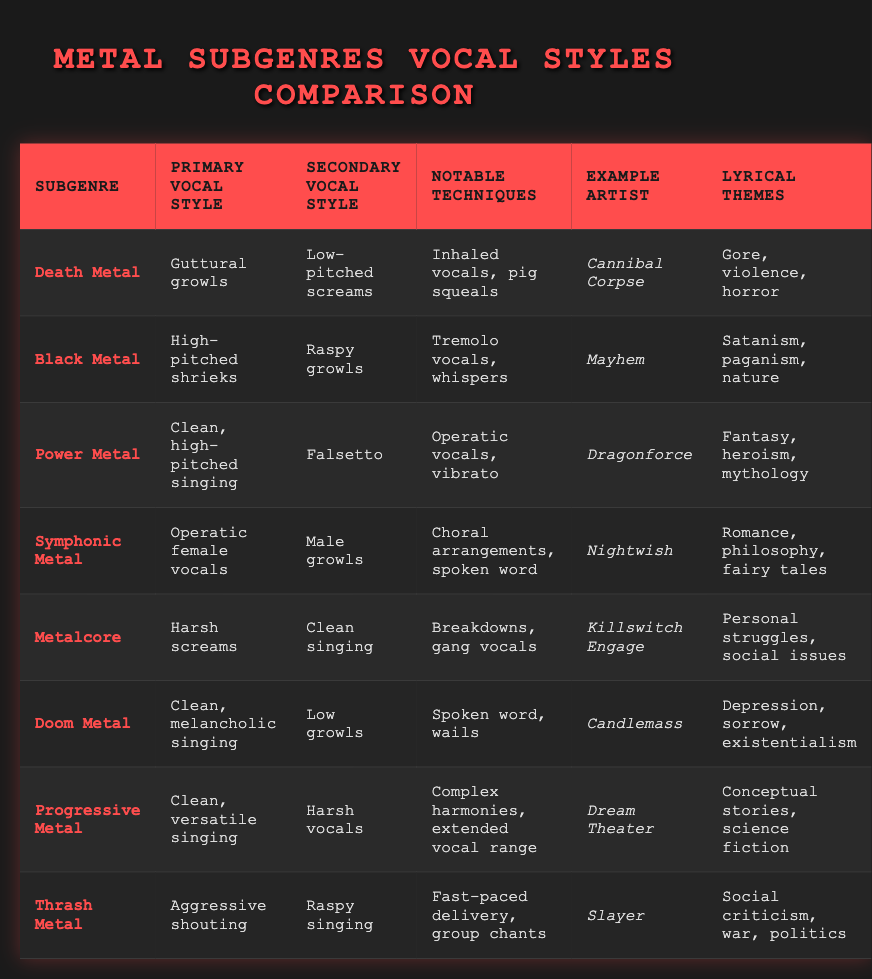What is the primary vocal style of Death Metal? The table shows that the primary vocal style of Death Metal is "Guttural growls." This information can be directly retrieved from the row corresponding to the Death Metal subgenre.
Answer: Guttural growls Which subgenre features operatic female vocals as the primary style? From the table, we can see that Symphonic Metal has "Operatic female vocals" listed as its primary vocal style, which is clearly stated in the corresponding row.
Answer: Symphonic Metal Is Killswitch Engage associated with clean singing style? The table indicates that Killswitch Engage, associated with Metalcore, employs "Clean singing" as a secondary vocal style. Since the question specifically asks if they are associated with "clean singing," the answer is yes.
Answer: Yes What notable techniques are used in Power Metal? Looking at the Power Metal row in the table, the notable techniques are listed as "Operatic vocals, vibrato." The response is simply stating what is recorded in that row.
Answer: Operatic vocals, vibrato Are harsh screams used in any subgenre other than Metalcore? By examining the table, we see that harsh screams are the primary vocal style in Metalcore, but they are also listed as a secondary vocal style in Progressive Metal. Hence, the answer to the question is yes.
Answer: Yes Which subgenres have lyrical themes related to violence or horror? In the table, Death Metal has lyrical themes of "Gore, violence, horror," which corresponds to the emotional weight of that genre. Additionally, Thrash Metal mentions "Social criticism, war, politics," which connects indirectly to violence. Thus, we can confirm Death Metal directly fits this theme, while Thrash Metal does so indirectly.
Answer: Death Metal What is the difference in primary vocal styles between Black Metal and Doom Metal? The primary vocal style for Black Metal is "High-pitched shrieks," while for Doom Metal, it is "Clean, melancholic singing." The difference is that one style is characterized by high pitches and the other by a cleaner, more melancholic sound.
Answer: High-pitched shrieks vs. Clean, melancholic singing Which artist is known for using male growls in their music? The table lists Nightwish as an example artist for Symphonic Metal, which features "Male growls" as the secondary vocal style. This confirms that Nightwish utilizes this type of vocalization in their music.
Answer: Nightwish What are the common lyrical themes found in Progressive Metal? The table indicates that Progressive Metal has "Conceptual stories, science fiction" as its lyrical themes. Therefore, this pair is specifically linked to the thematic content of the subgenre.
Answer: Conceptual stories, science fiction 